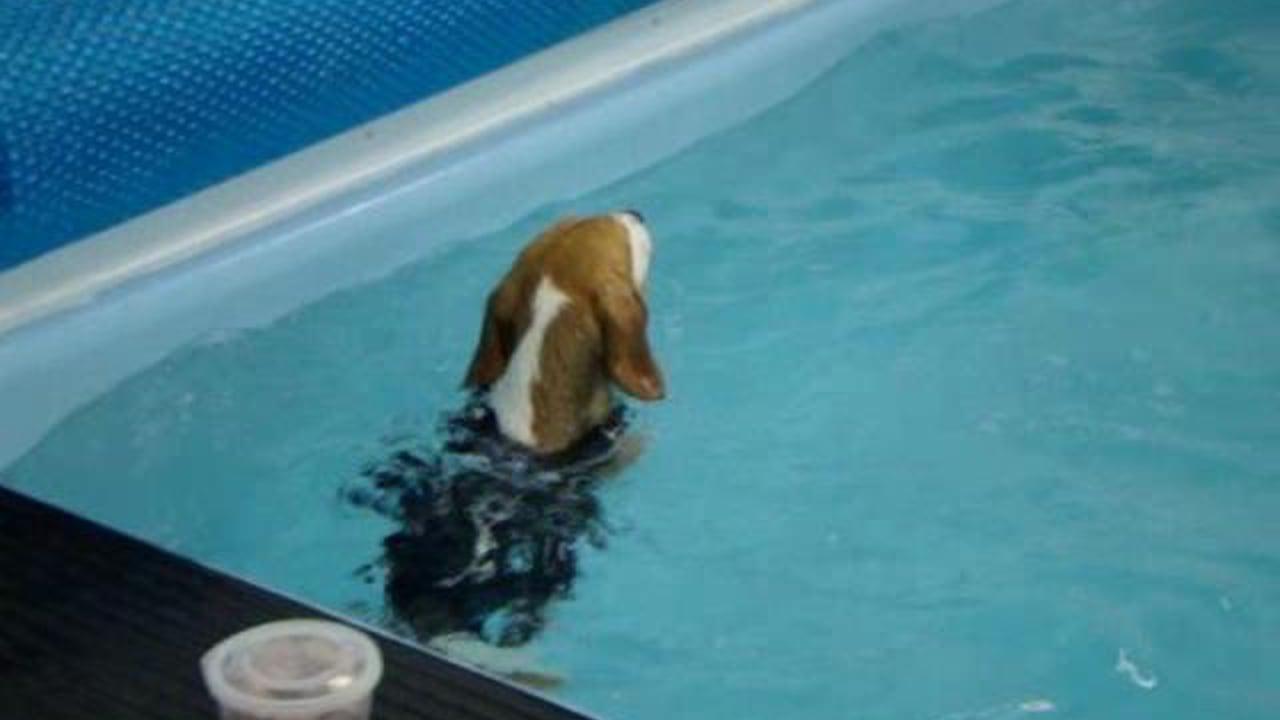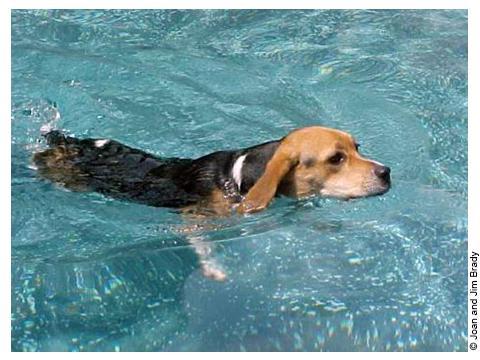The first image is the image on the left, the second image is the image on the right. Given the left and right images, does the statement "There are two beagles swimming and both of them have their heads above water." hold true? Answer yes or no. Yes. 